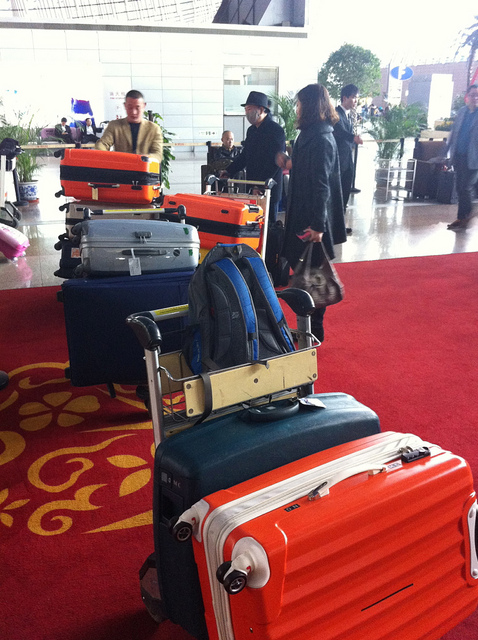<image>Which airport is this? I don't know which airport this is. It could be 'lax', 'chinese', 'bwi' or 'atlanta'. Which airport is this? It is ambiguous which airport is shown in the image. It could be LAX, BWI, or Atlanta. 